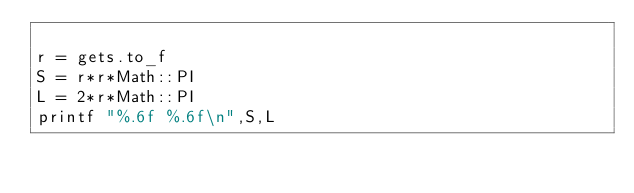<code> <loc_0><loc_0><loc_500><loc_500><_Ruby_>
r = gets.to_f
S = r*r*Math::PI
L = 2*r*Math::PI
printf "%.6f %.6f\n",S,L</code> 